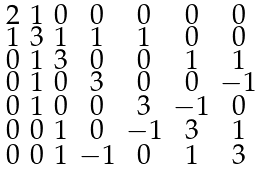Convert formula to latex. <formula><loc_0><loc_0><loc_500><loc_500>\begin{smallmatrix} 2 & 1 & 0 & 0 & 0 & 0 & 0 \\ 1 & 3 & 1 & 1 & 1 & 0 & 0 \\ 0 & 1 & 3 & 0 & 0 & 1 & 1 \\ 0 & 1 & 0 & 3 & 0 & 0 & - 1 \\ 0 & 1 & 0 & 0 & 3 & - 1 & 0 \\ 0 & 0 & 1 & 0 & - 1 & 3 & 1 \\ 0 & 0 & 1 & - 1 & 0 & 1 & 3 \end{smallmatrix}</formula> 